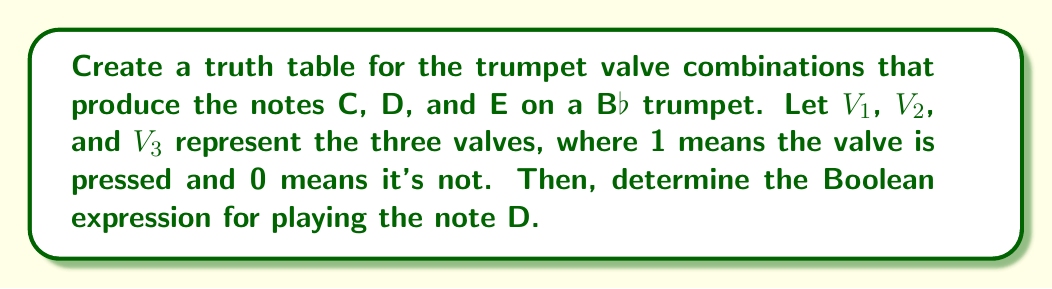Teach me how to tackle this problem. Let's approach this step-by-step:

1) First, we need to know the valve combinations for C, D, and E on a B♭ trumpet:
   C: No valves pressed (0 0 0)
   D: Valves 1 and 3 pressed (1 0 1)
   E: Valves 1 and 2 pressed (1 1 0)

2) Now, let's create the truth table:

   $$
   \begin{array}{|c|c|c|c|c|c|}
   \hline
   V_1 & V_2 & V_3 & C & D & E \\
   \hline
   0 & 0 & 0 & 1 & 0 & 0 \\
   0 & 0 & 1 & 0 & 0 & 0 \\
   0 & 1 & 0 & 0 & 0 & 0 \\
   0 & 1 & 1 & 0 & 0 & 0 \\
   1 & 0 & 0 & 0 & 0 & 0 \\
   1 & 0 & 1 & 0 & 1 & 0 \\
   1 & 1 & 0 & 0 & 0 & 1 \\
   1 & 1 & 1 & 0 & 0 & 0 \\
   \hline
   \end{array}
   $$

3) To determine the Boolean expression for playing the note D, we look at the row where D is 1:
   $V_1 = 1$, $V_2 = 0$, $V_3 = 1$

4) The Boolean expression for D is therefore:

   $D = V_1 \cdot \overline{V_2} \cdot V_3$

   This means "Valve 1 AND (NOT Valve 2) AND Valve 3"
Answer: $D = V_1 \cdot \overline{V_2} \cdot V_3$ 